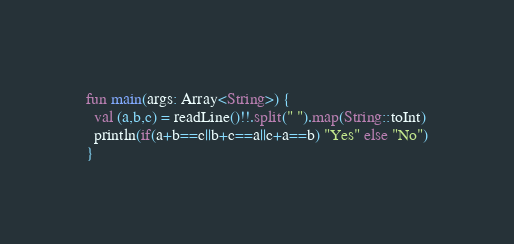<code> <loc_0><loc_0><loc_500><loc_500><_Kotlin_>fun main(args: Array<String>) {
  val (a,b,c) = readLine()!!.split(" ").map(String::toInt)
  println(if(a+b==c||b+c==a||c+a==b) "Yes" else "No")
}</code> 